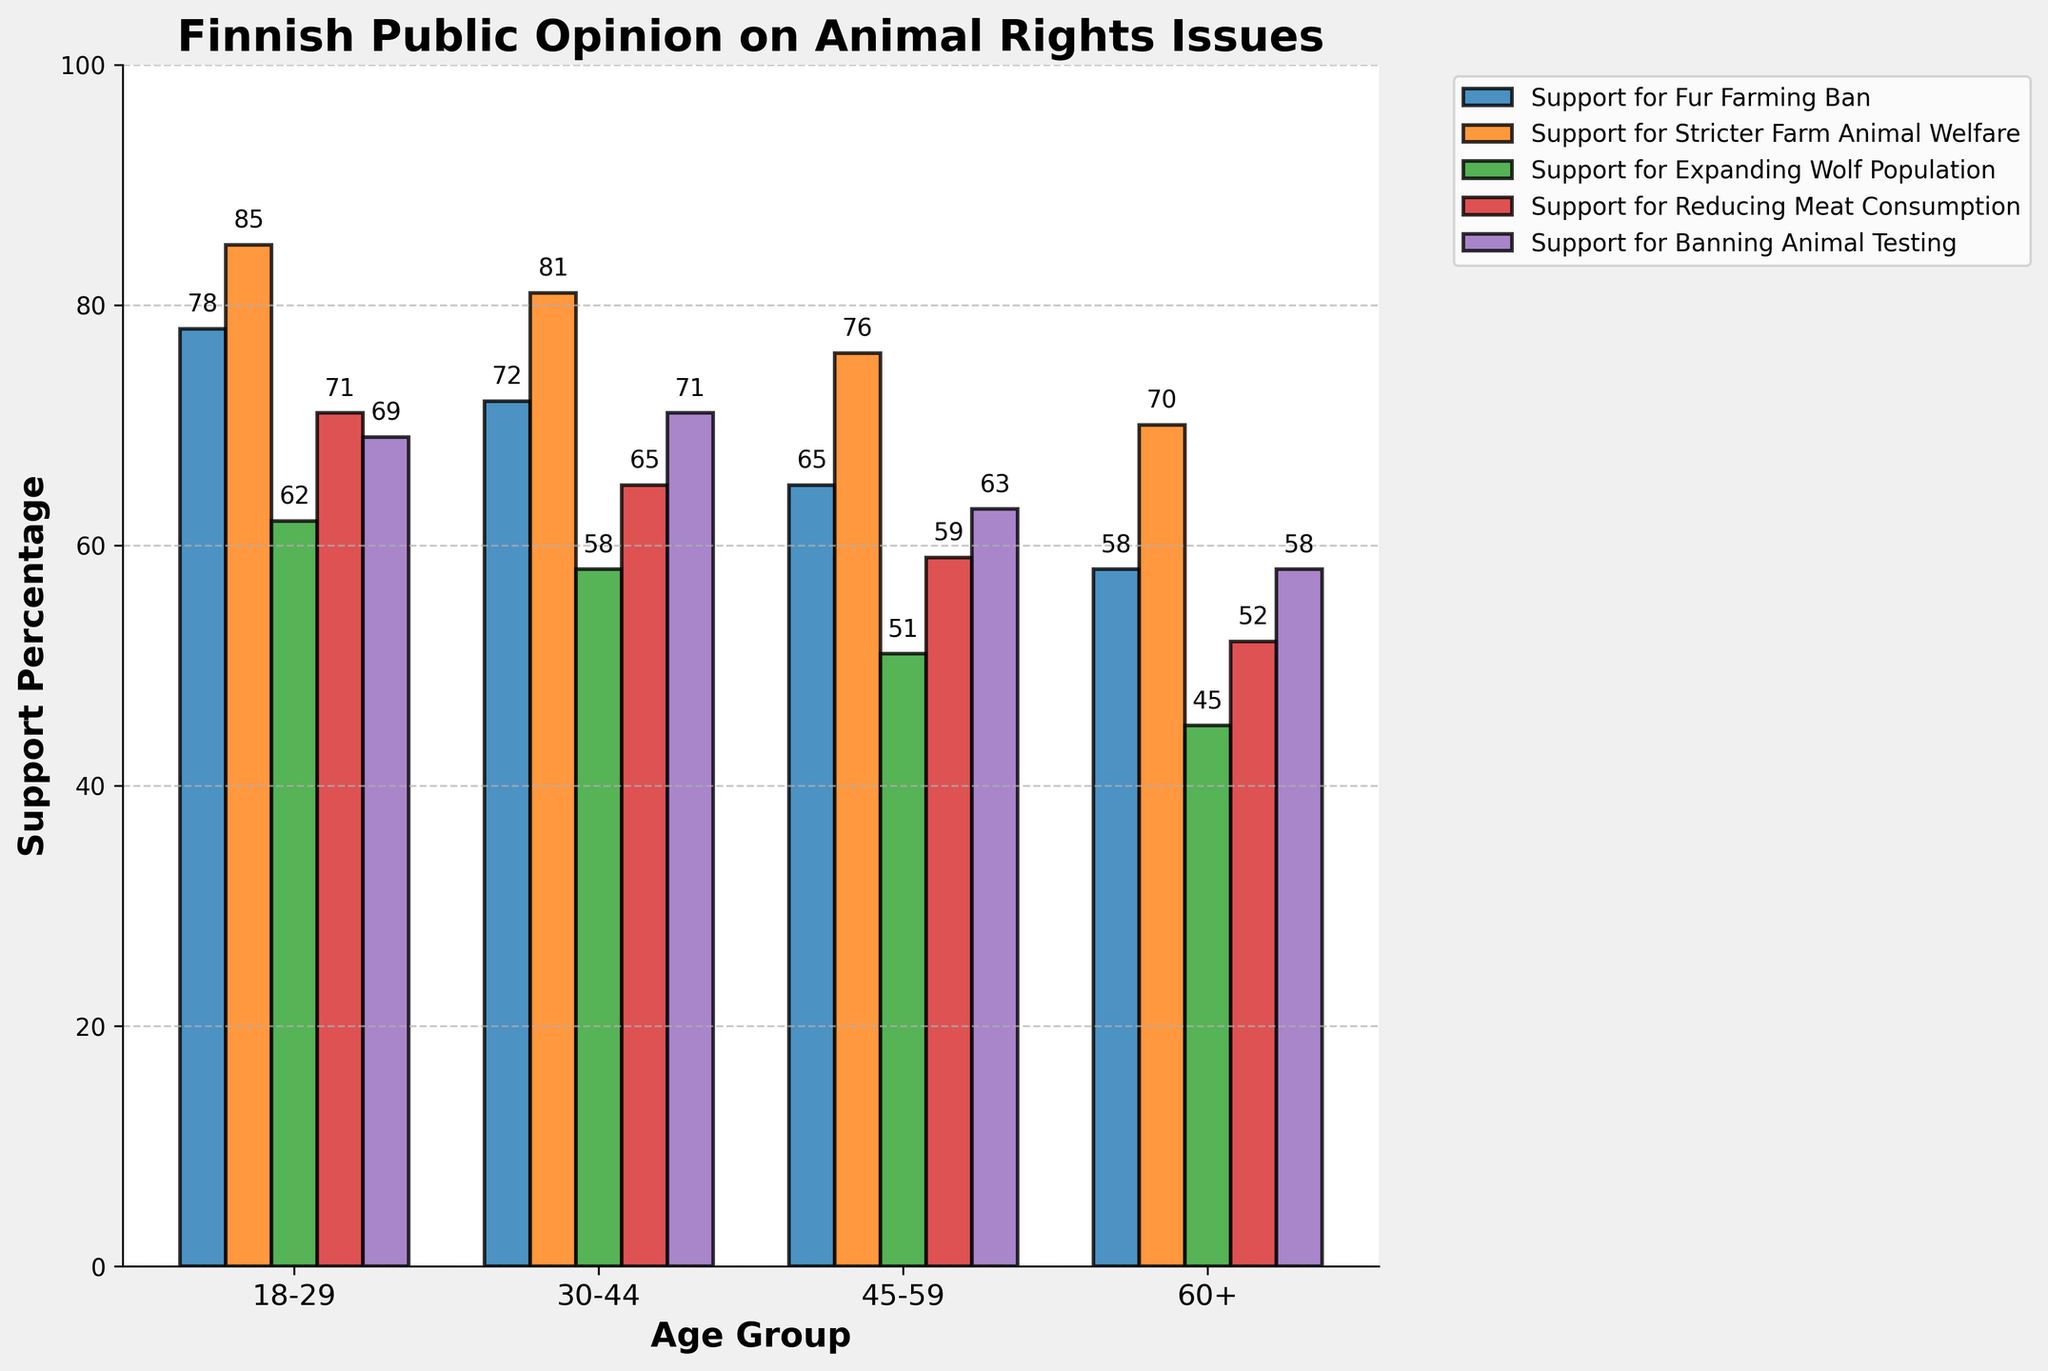Which age group has the highest support for banning fur farming? Observe the heights of the bars corresponding to "Support for Fur Farming Ban." The highest bar is at 78% for the 18-29 age group.
Answer: 18-29 What is the difference in support for reducing meat consumption between the 30-44 and 60+ age groups? Check the height of the bars for "Support for Reducing Meat Consumption" for both age groups. The values are 65% for 30-44 and 52% for 60+. The difference is 65 - 52 = 13%.
Answer: 13% Which age group has the lowest support for expanding the wolf population? Look at the bars labeled "Support for Expanding Wolf Population" across all age groups. The lowest value is 45% for the 60+ age group.
Answer: 60+ Calculate the average support percentage across all issues for the 18-29 age group. Add the values for the 18-29 age group: (78 + 85 + 62 + 71 + 69) = 365. The average is 365 / 5 = 73%.
Answer: 73% Is there any age group that consistently has the highest support for all issues? Compare the heights of the bars for each issue across all age groups. The 18-29 age group consistently has the highest values for every issue.
Answer: Yes Which two age groups have the closest support percentages for banning animal testing? Compare the "Support for Banning Animal Testing" values, which are 69% (18-29), 71% (30-44), 63% (45-59), and 58% (60+). The 18-29 and 45-59 age groups have a difference of 69 - 63 = 6%.
Answer: 18-29 and 45-59 If a new policy needed more than 50% support from any two age groups to pass, which issue would meet this criterion across all age groups? Check each issue to see if two age groups have support over 50%. All issues have more than 50% support across multiple age groups. However, "Support for Stricter Farm Animal Welfare" has the highest uniformity.
Answer: Stricter Farm Animal Welfare Which issue shows the largest decrease in support from the 18-29 to the 60+ age group? Calculate the differences for each issue: Fur Farming Ban: 78-58=20, Stricter Farm Animal Welfare: 85-70=15, Expanding Wolf Population: 62-45=17, Reducing Meat Consumption: 71-52=19, Banning Animal Testing: 69-58=11. The largest decrease is for Fur Farming Ban.
Answer: Fur Farming Ban What is the total support percentage for stricter farm animal welfare across all age groups? Sum the values for "Support for Stricter Farm Animal Welfare": 85 + 81 + 76 + 70 = 312%.
Answer: 312% Between the 30-44 and 45-59 age groups, which has higher support for reducing meat consumption? By how much? Compare the heights of the bars for "Support for Reducing Meat Consumption" between 30-44 (65%) and 45-59 (59%). The 30-44 age group is higher by 6%.
Answer: 30-44, 6% 